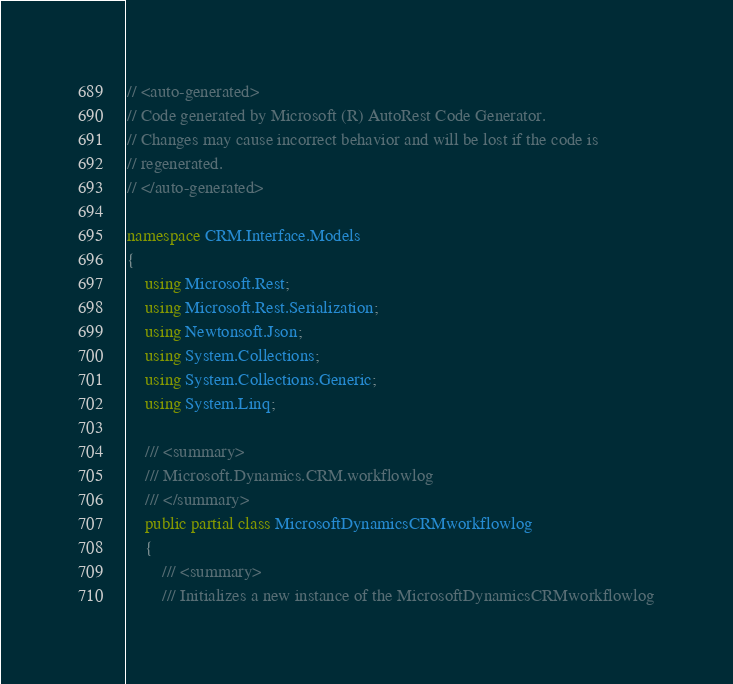<code> <loc_0><loc_0><loc_500><loc_500><_C#_>// <auto-generated>
// Code generated by Microsoft (R) AutoRest Code Generator.
// Changes may cause incorrect behavior and will be lost if the code is
// regenerated.
// </auto-generated>

namespace CRM.Interface.Models
{
    using Microsoft.Rest;
    using Microsoft.Rest.Serialization;
    using Newtonsoft.Json;
    using System.Collections;
    using System.Collections.Generic;
    using System.Linq;

    /// <summary>
    /// Microsoft.Dynamics.CRM.workflowlog
    /// </summary>
    public partial class MicrosoftDynamicsCRMworkflowlog
    {
        /// <summary>
        /// Initializes a new instance of the MicrosoftDynamicsCRMworkflowlog</code> 